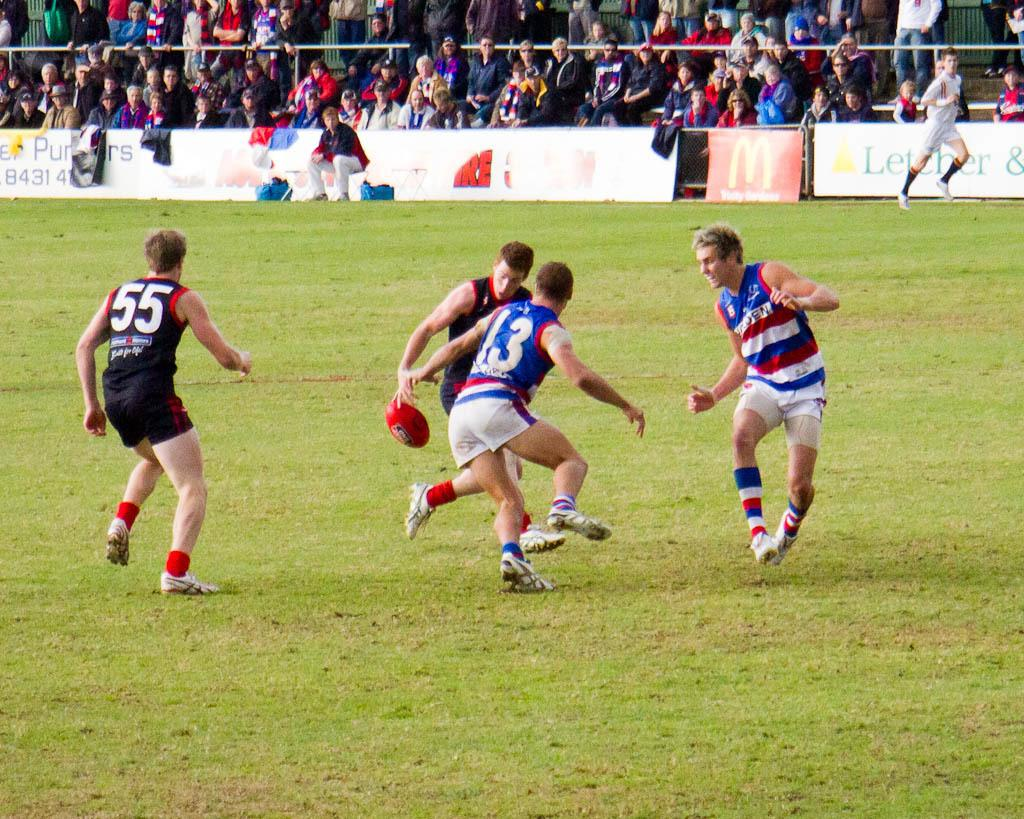<image>
Write a terse but informative summary of the picture. a player that has the number 3 on their jersey 